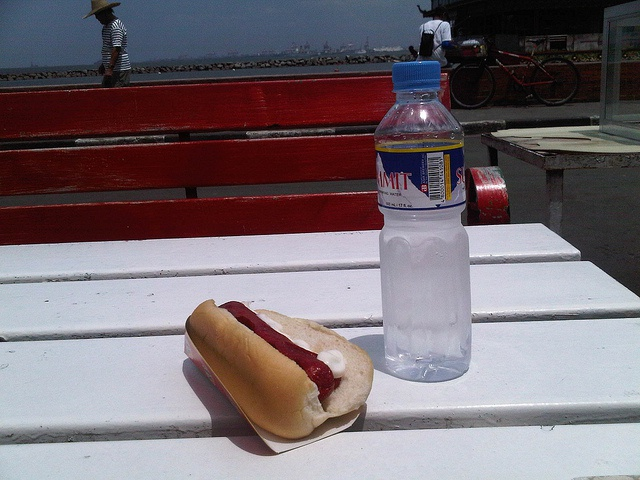Describe the objects in this image and their specific colors. I can see bench in darkblue, lightgray, maroon, black, and gray tones, dining table in darkblue, lightgray, gray, and darkgray tones, bottle in darkblue, darkgray, gray, and black tones, hot dog in darkblue, maroon, darkgray, and brown tones, and dining table in darkblue, black, gray, and darkgray tones in this image. 